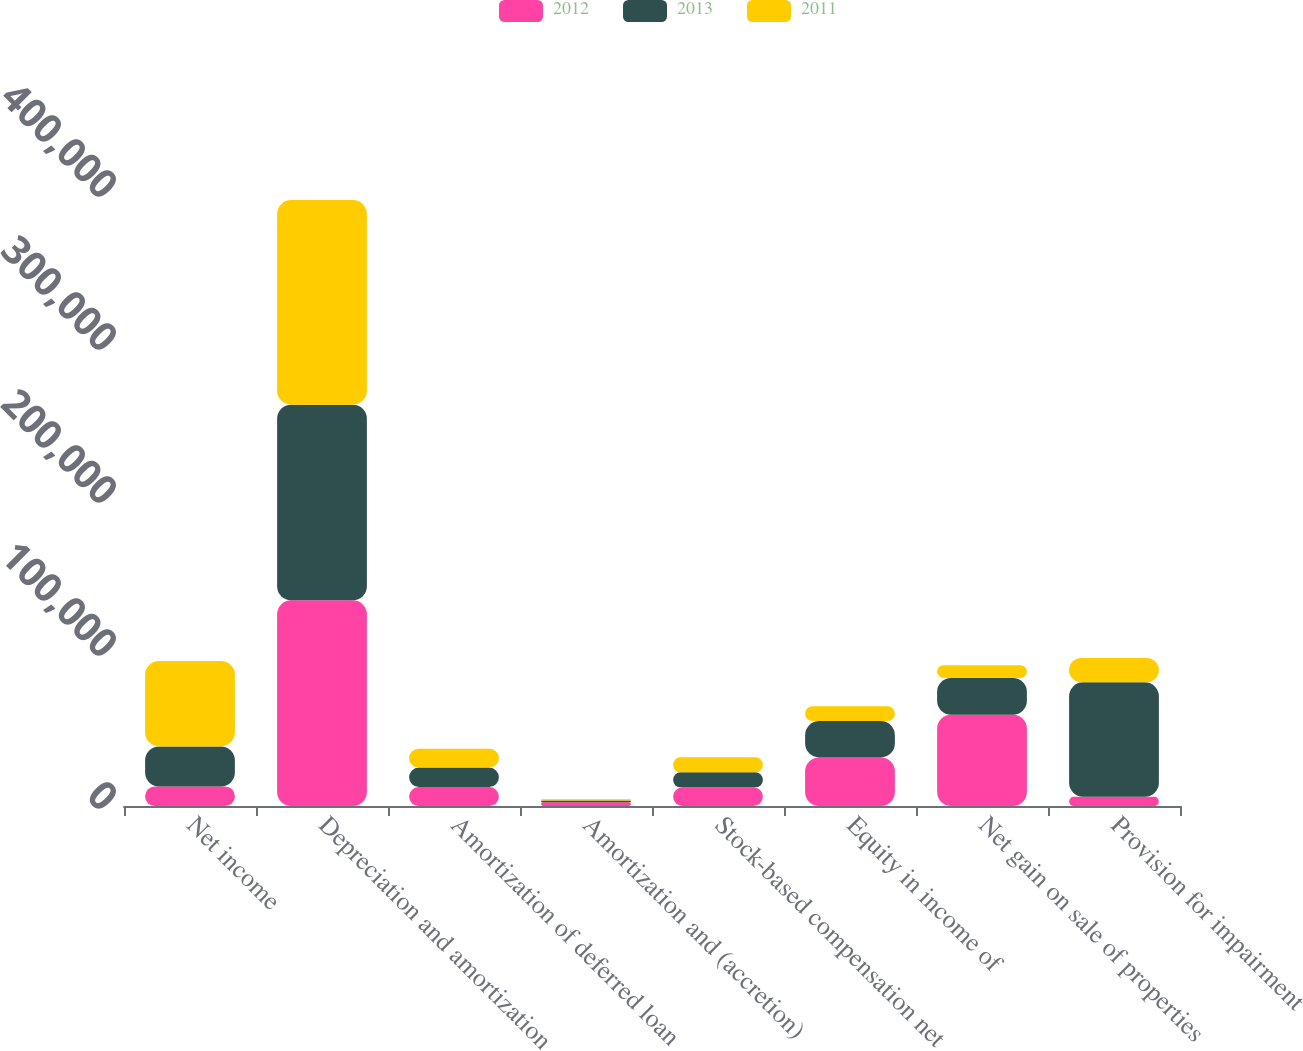Convert chart. <chart><loc_0><loc_0><loc_500><loc_500><stacked_bar_chart><ecel><fcel>Net income<fcel>Depreciation and amortization<fcel>Amortization of deferred loan<fcel>Amortization and (accretion)<fcel>Stock-based compensation net<fcel>Equity in income of<fcel>Net gain on sale of properties<fcel>Provision for impairment<nl><fcel>2012<fcel>12759<fcel>134454<fcel>12339<fcel>2488<fcel>12191<fcel>31718<fcel>59656<fcel>6000<nl><fcel>2013<fcel>26209<fcel>127839<fcel>12759<fcel>1043<fcel>9806<fcel>23807<fcel>24013<fcel>74816<nl><fcel>2011<fcel>55788<fcel>133756<fcel>12327<fcel>931<fcel>9824<fcel>9643<fcel>8346<fcel>15883<nl></chart> 